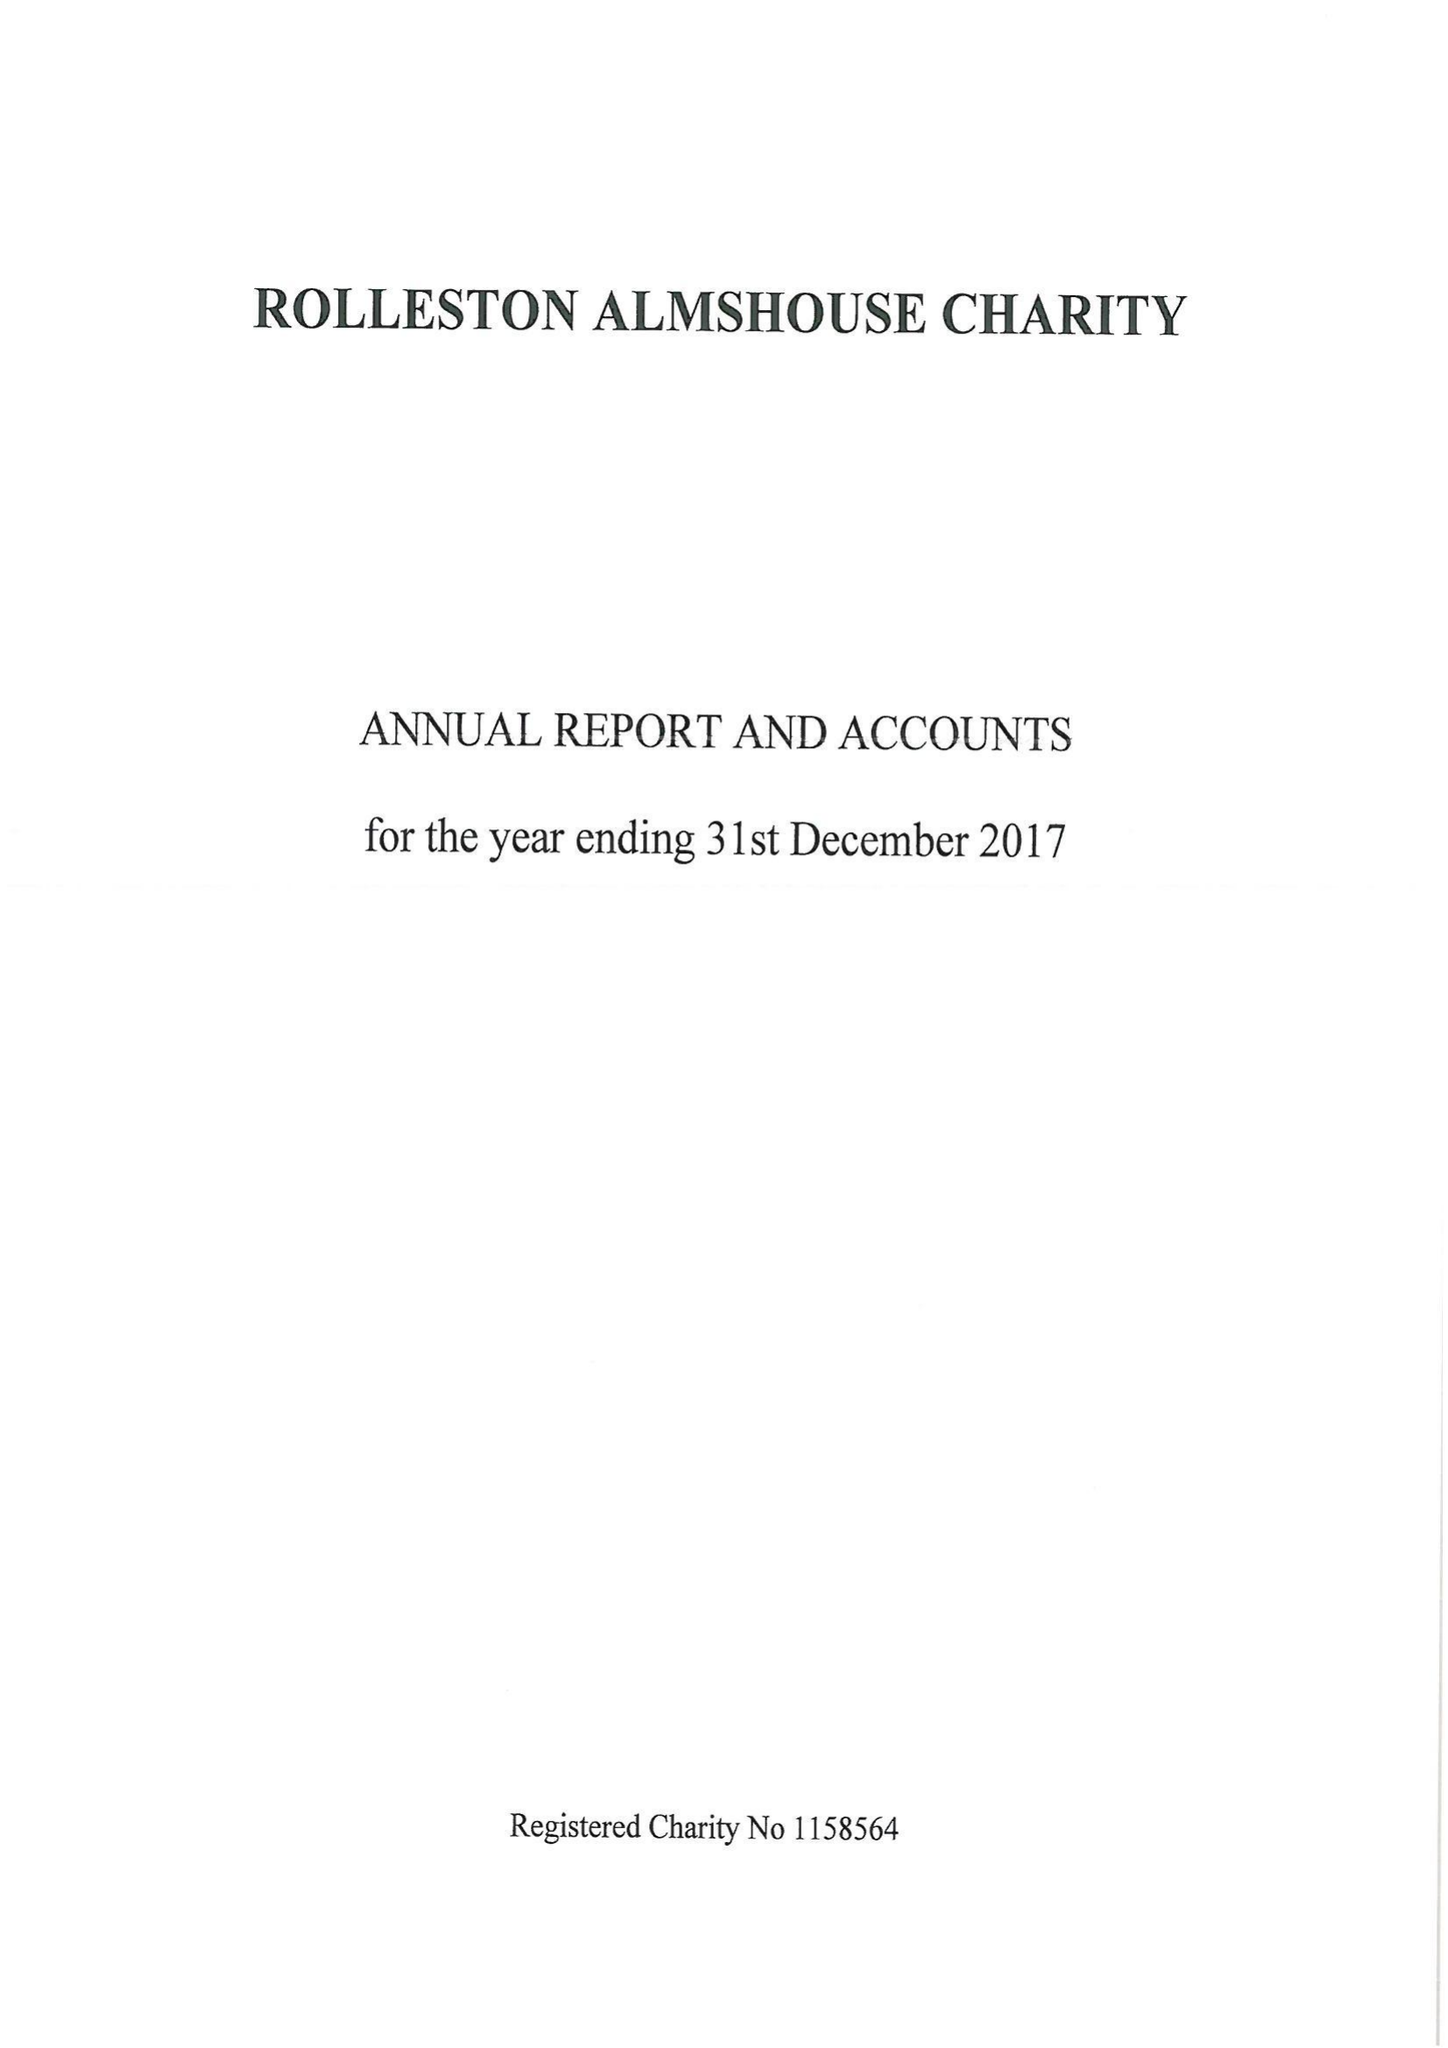What is the value for the charity_name?
Answer the question using a single word or phrase. Rolleston Almshouse Charity 